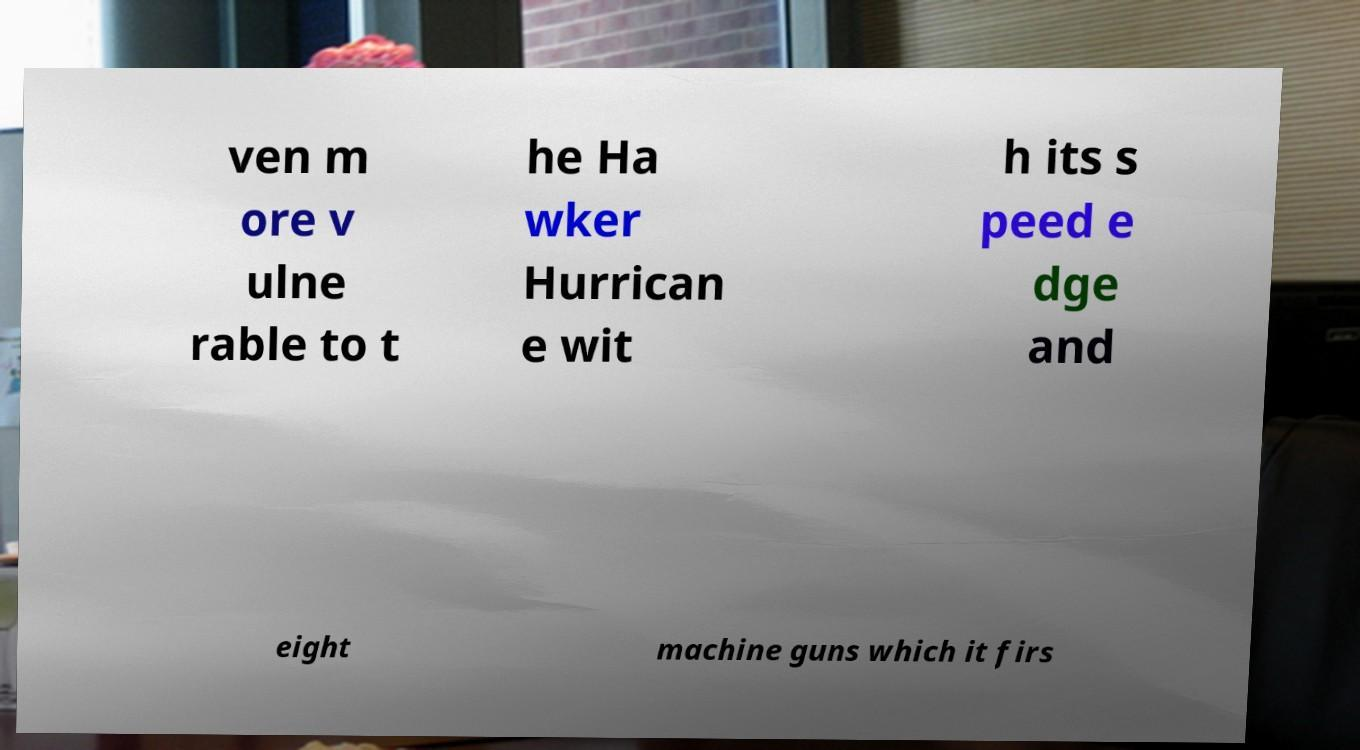There's text embedded in this image that I need extracted. Can you transcribe it verbatim? ven m ore v ulne rable to t he Ha wker Hurrican e wit h its s peed e dge and eight machine guns which it firs 